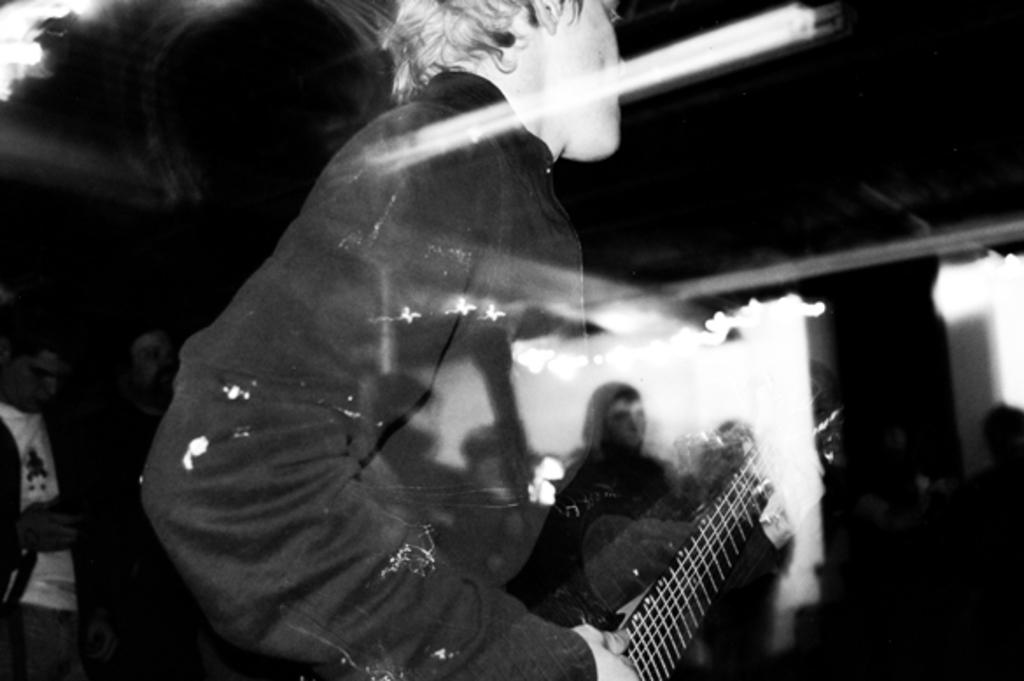Who or what is the main subject in the image? There is a person in the image. Can you describe the background of the image? The background of the image is blurry. What type of canvas is the zebra standing on in the image? There is no canvas or zebra present in the image; it only features a person with a blurry background. 